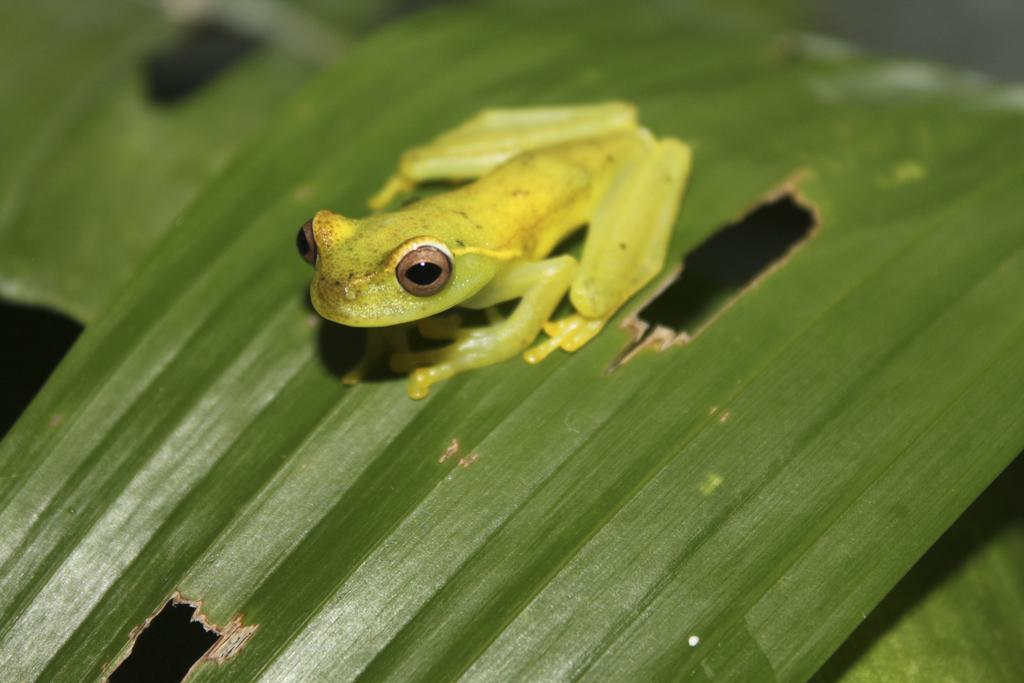What is the main subject in the center of the image? There is a frog in the center of the image. What can be seen in the background of the image? There are leaves visible in the background of the image. What type of farming equipment can be seen in the image? There is no farming equipment present in the image. What part of the human body is visible in the image? There are no human body parts visible in the image. What type of secret agent activity is happening in the image? There is no secret agent activity or spy present in the image. 